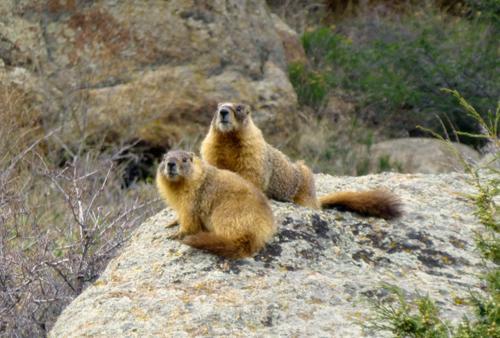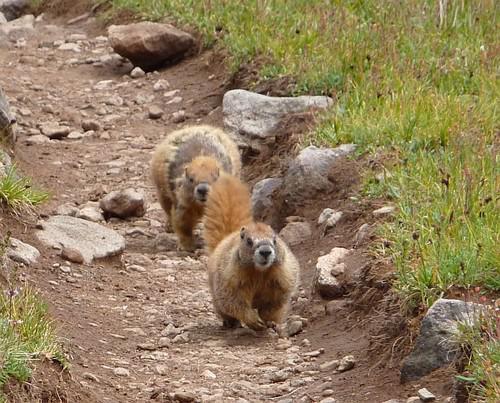The first image is the image on the left, the second image is the image on the right. Examine the images to the left and right. Is the description "Each image contains two animals, and at least two of the animals are touching." accurate? Answer yes or no. No. 